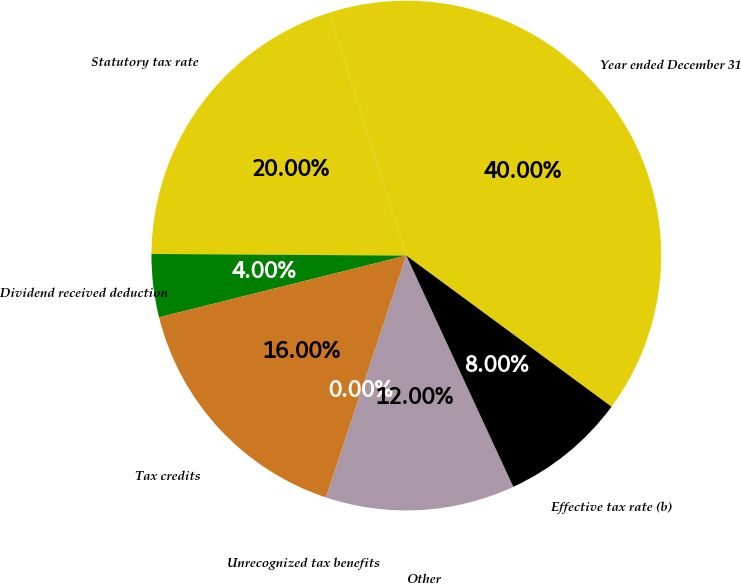Convert chart. <chart><loc_0><loc_0><loc_500><loc_500><pie_chart><fcel>Year ended December 31<fcel>Statutory tax rate<fcel>Dividend received deduction<fcel>Tax credits<fcel>Unrecognized tax benefits<fcel>Other<fcel>Effective tax rate (b)<nl><fcel>40.0%<fcel>20.0%<fcel>4.0%<fcel>16.0%<fcel>0.0%<fcel>12.0%<fcel>8.0%<nl></chart> 